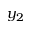Convert formula to latex. <formula><loc_0><loc_0><loc_500><loc_500>y _ { 2 }</formula> 